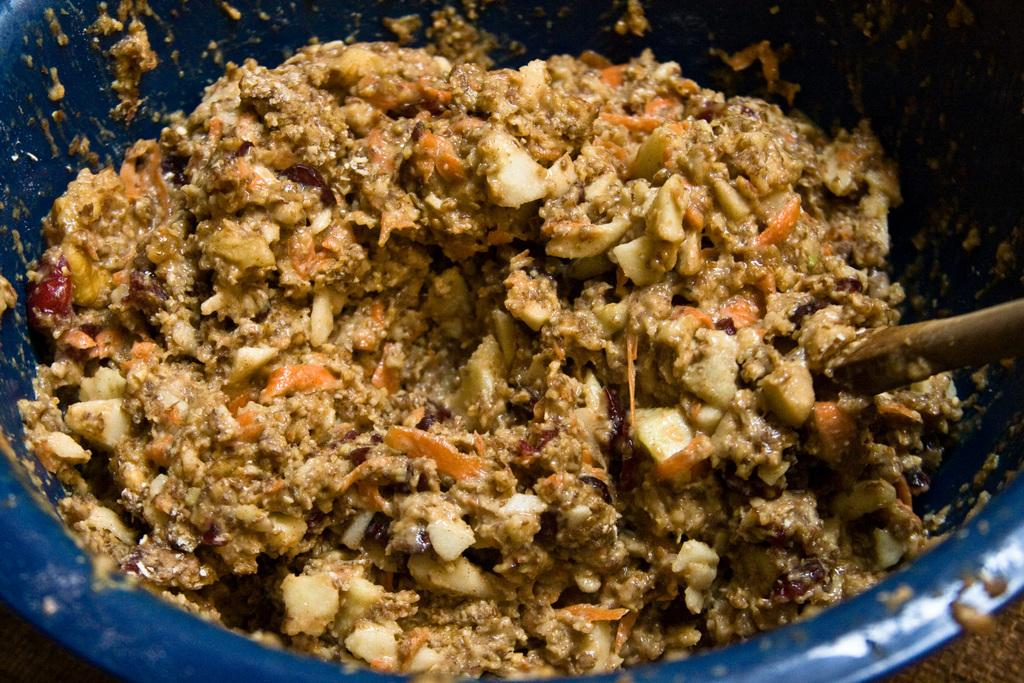What color is the bowl in the image? The bowl in the image is blue. What material is the spoon in the image made of? The spoon in the image is made of wood. What is inside the blue bowl? There is a food item in the blue bowl. What type of chalk is being used to draw on the school wall in the image? There is no chalk or school wall present in the image. 